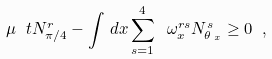<formula> <loc_0><loc_0><loc_500><loc_500>\mu \ t N _ { \pi / 4 } ^ { r } - \int \, d x \sum _ { s = 1 } ^ { 4 } \ \omega _ { x } ^ { r s } N _ { \theta \, _ { x } } ^ { s } \geq 0 \ ,</formula> 